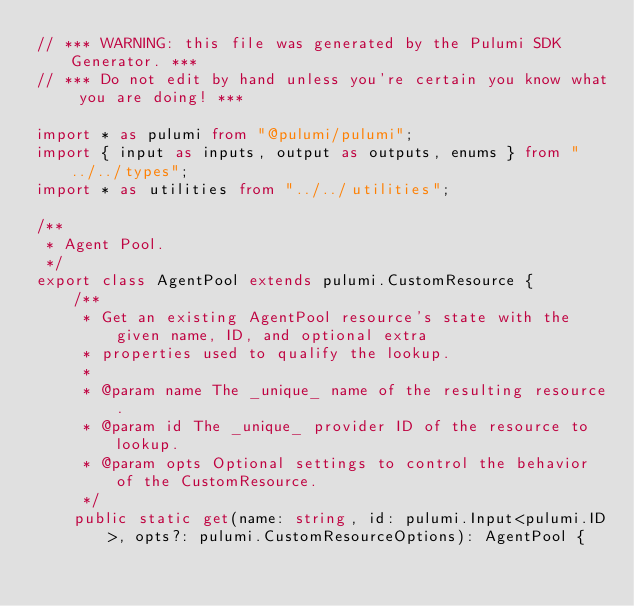<code> <loc_0><loc_0><loc_500><loc_500><_TypeScript_>// *** WARNING: this file was generated by the Pulumi SDK Generator. ***
// *** Do not edit by hand unless you're certain you know what you are doing! ***

import * as pulumi from "@pulumi/pulumi";
import { input as inputs, output as outputs, enums } from "../../types";
import * as utilities from "../../utilities";

/**
 * Agent Pool.
 */
export class AgentPool extends pulumi.CustomResource {
    /**
     * Get an existing AgentPool resource's state with the given name, ID, and optional extra
     * properties used to qualify the lookup.
     *
     * @param name The _unique_ name of the resulting resource.
     * @param id The _unique_ provider ID of the resource to lookup.
     * @param opts Optional settings to control the behavior of the CustomResource.
     */
    public static get(name: string, id: pulumi.Input<pulumi.ID>, opts?: pulumi.CustomResourceOptions): AgentPool {</code> 